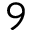Convert formula to latex. <formula><loc_0><loc_0><loc_500><loc_500>9</formula> 